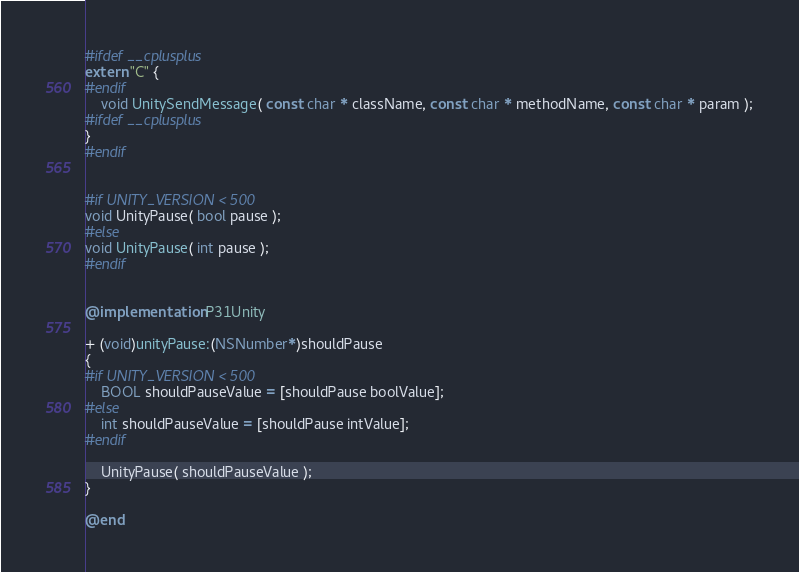Convert code to text. <code><loc_0><loc_0><loc_500><loc_500><_ObjectiveC_>
#ifdef __cplusplus
extern "C" {
#endif
	void UnitySendMessage( const char * className, const char * methodName, const char * param );
#ifdef __cplusplus
}
#endif


#if UNITY_VERSION < 500
void UnityPause( bool pause );
#else
void UnityPause( int pause );
#endif


@implementation P31Unity

+ (void)unityPause:(NSNumber*)shouldPause
{
#if UNITY_VERSION < 500
	BOOL shouldPauseValue = [shouldPause boolValue];
#else
	int shouldPauseValue = [shouldPause intValue];
#endif
	
	UnityPause( shouldPauseValue );
}

@end
</code> 